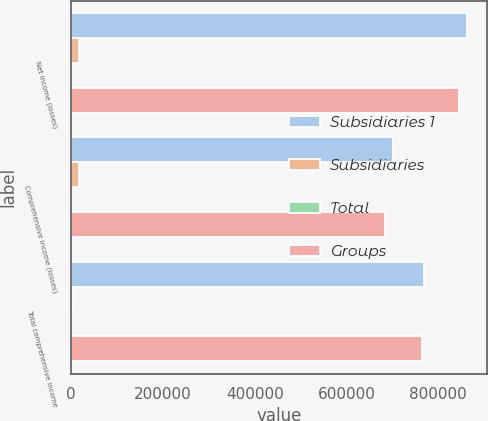Convert chart to OTSL. <chart><loc_0><loc_0><loc_500><loc_500><stacked_bar_chart><ecel><fcel>Net income (losses)<fcel>Comprehensive income (losses)<fcel>Total comprehensive income<nl><fcel>Subsidiaries 1<fcel>863330<fcel>700742<fcel>769853<nl><fcel>Subsidiaries<fcel>17257<fcel>17257<fcel>4481<nl><fcel>Total<fcel>308<fcel>308<fcel>274<nl><fcel>Groups<fcel>846381<fcel>683793<fcel>765646<nl></chart> 